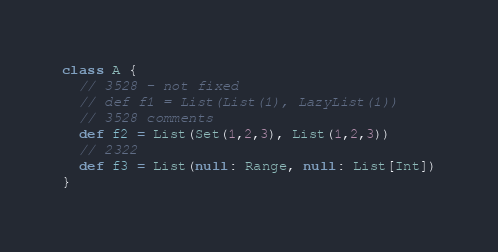Convert code to text. <code><loc_0><loc_0><loc_500><loc_500><_Scala_>class A {
  // 3528 - not fixed
  // def f1 = List(List(1), LazyList(1))
  // 3528 comments
  def f2 = List(Set(1,2,3), List(1,2,3))
  // 2322
  def f3 = List(null: Range, null: List[Int])
}
</code> 